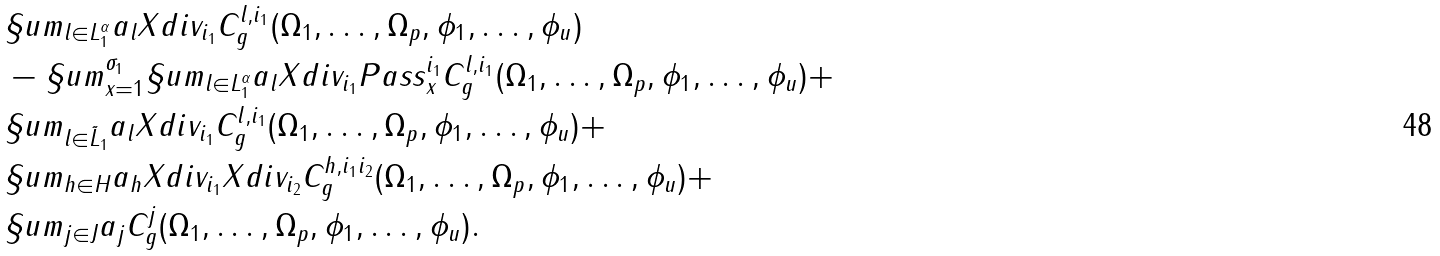Convert formula to latex. <formula><loc_0><loc_0><loc_500><loc_500>& \S u m _ { l \in L _ { 1 } ^ { \alpha } } a _ { l } X d i v _ { i _ { 1 } } C ^ { l , i _ { 1 } } _ { g } ( \Omega _ { 1 } , \dots , \Omega _ { p } , \phi _ { 1 } , \dots , \phi _ { u } ) \\ & - \S u m _ { x = 1 } ^ { \sigma _ { 1 } } \S u m _ { l \in L _ { 1 } ^ { \alpha } } a _ { l } X d i v _ { i _ { 1 } } P a s s _ { x } ^ { i _ { 1 } } C ^ { l , i _ { 1 } } _ { g } ( \Omega _ { 1 } , \dots , \Omega _ { p } , \phi _ { 1 } , \dots , \phi _ { u } ) + \\ & \S u m _ { l \in \tilde { L } _ { 1 } } a _ { l } X d i v _ { i _ { 1 } } C ^ { l , i _ { 1 } } _ { g } ( \Omega _ { 1 } , \dots , \Omega _ { p } , \phi _ { 1 } , \dots , \phi _ { u } ) + \\ & \S u m _ { h \in H } a _ { h } X d i v _ { i _ { 1 } } X d i v _ { i _ { 2 } } C ^ { h , i _ { 1 } i _ { 2 } } _ { g } ( \Omega _ { 1 } , \dots , \Omega _ { p } , \phi _ { 1 } , \dots , \phi _ { u } ) + \\ & \S u m _ { j \in J } a _ { j } C ^ { j } _ { g } ( \Omega _ { 1 } , \dots , \Omega _ { p } , \phi _ { 1 } , \dots , \phi _ { u } ) .</formula> 